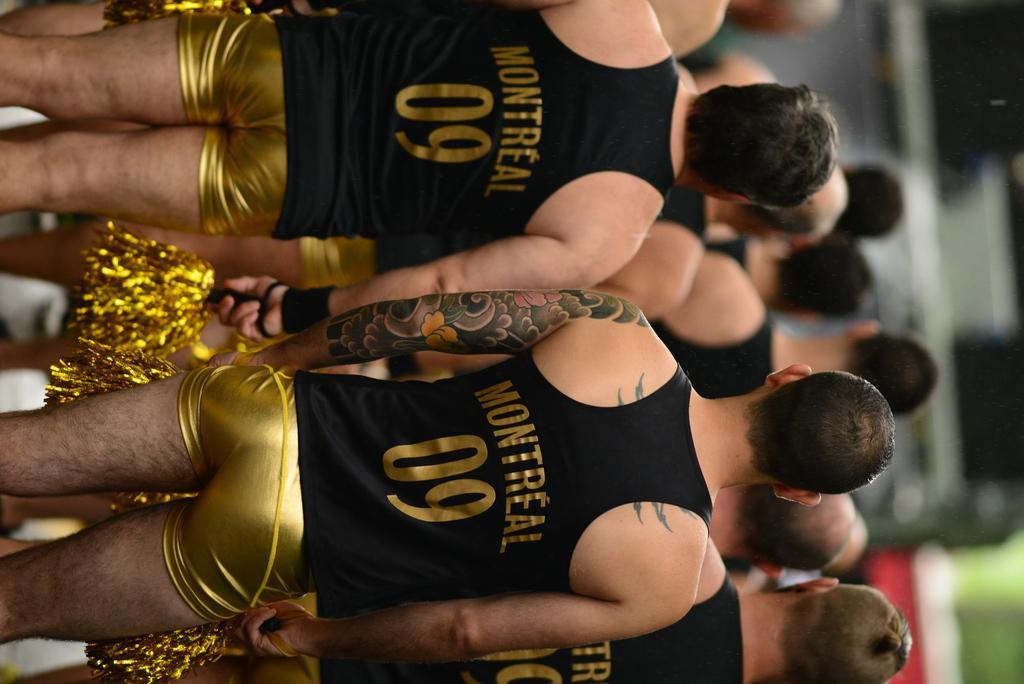How would you summarize this image in a sentence or two? In this image we can see a group of people are standing and wore black and gold color dress and holding something in their hands. 